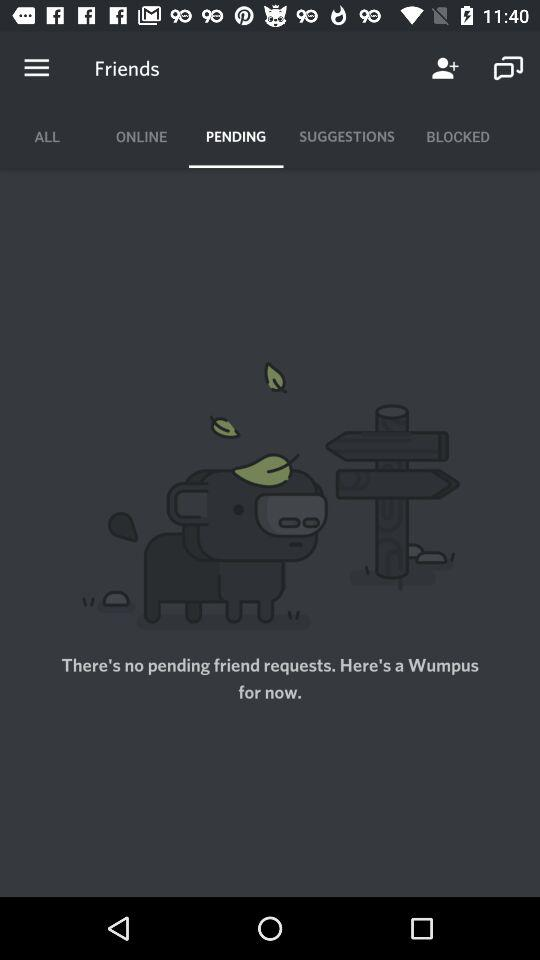Which tab is selected? The selected tab is "PENDING". 